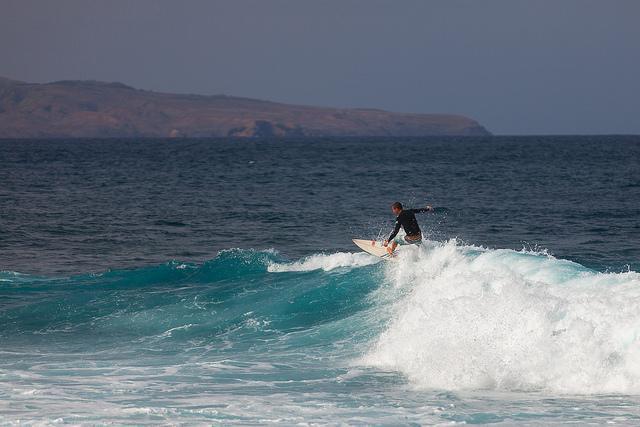How many people are surfing?
Give a very brief answer. 1. How many people are in this picture?
Give a very brief answer. 1. How many water vehicles are there?
Give a very brief answer. 0. How many of the posts ahve clocks on them?
Give a very brief answer. 0. 